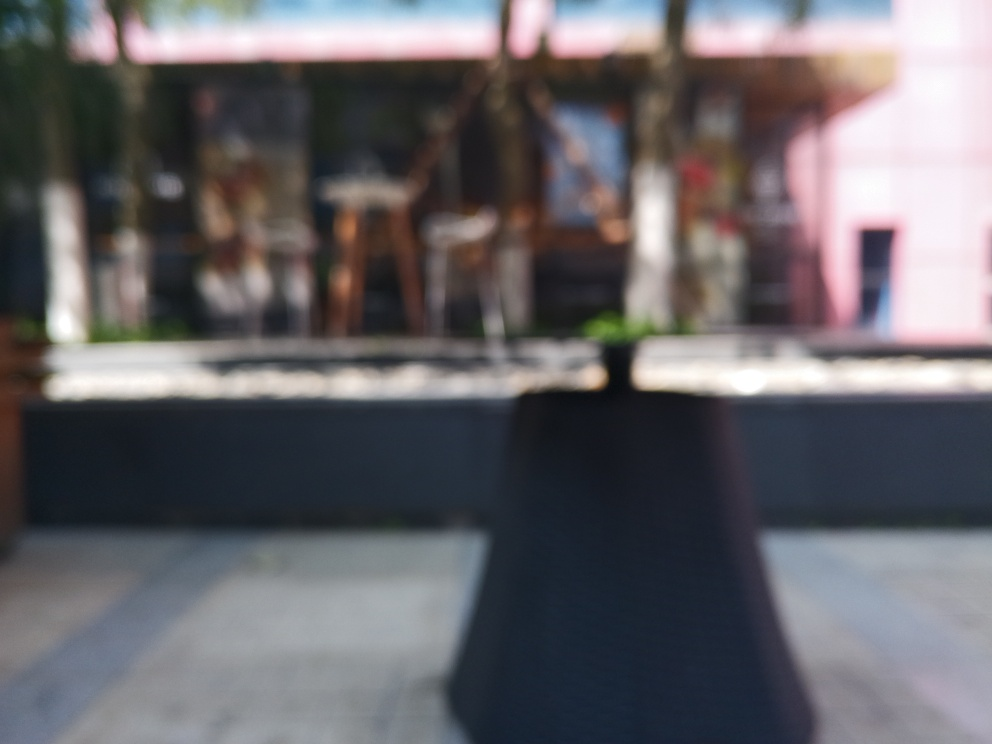Could the blurriness be intentional, and if so, what effect might it be trying to achieve? Artistically, a photographer may deliberately use blurriness to create a sense of mystery, emphasize movement, or convey a dreamlike quality. Blurring can abstract the reality of the scene, compelling the viewer to focus on the overall mood or emotional resonance rather than the specific details. 